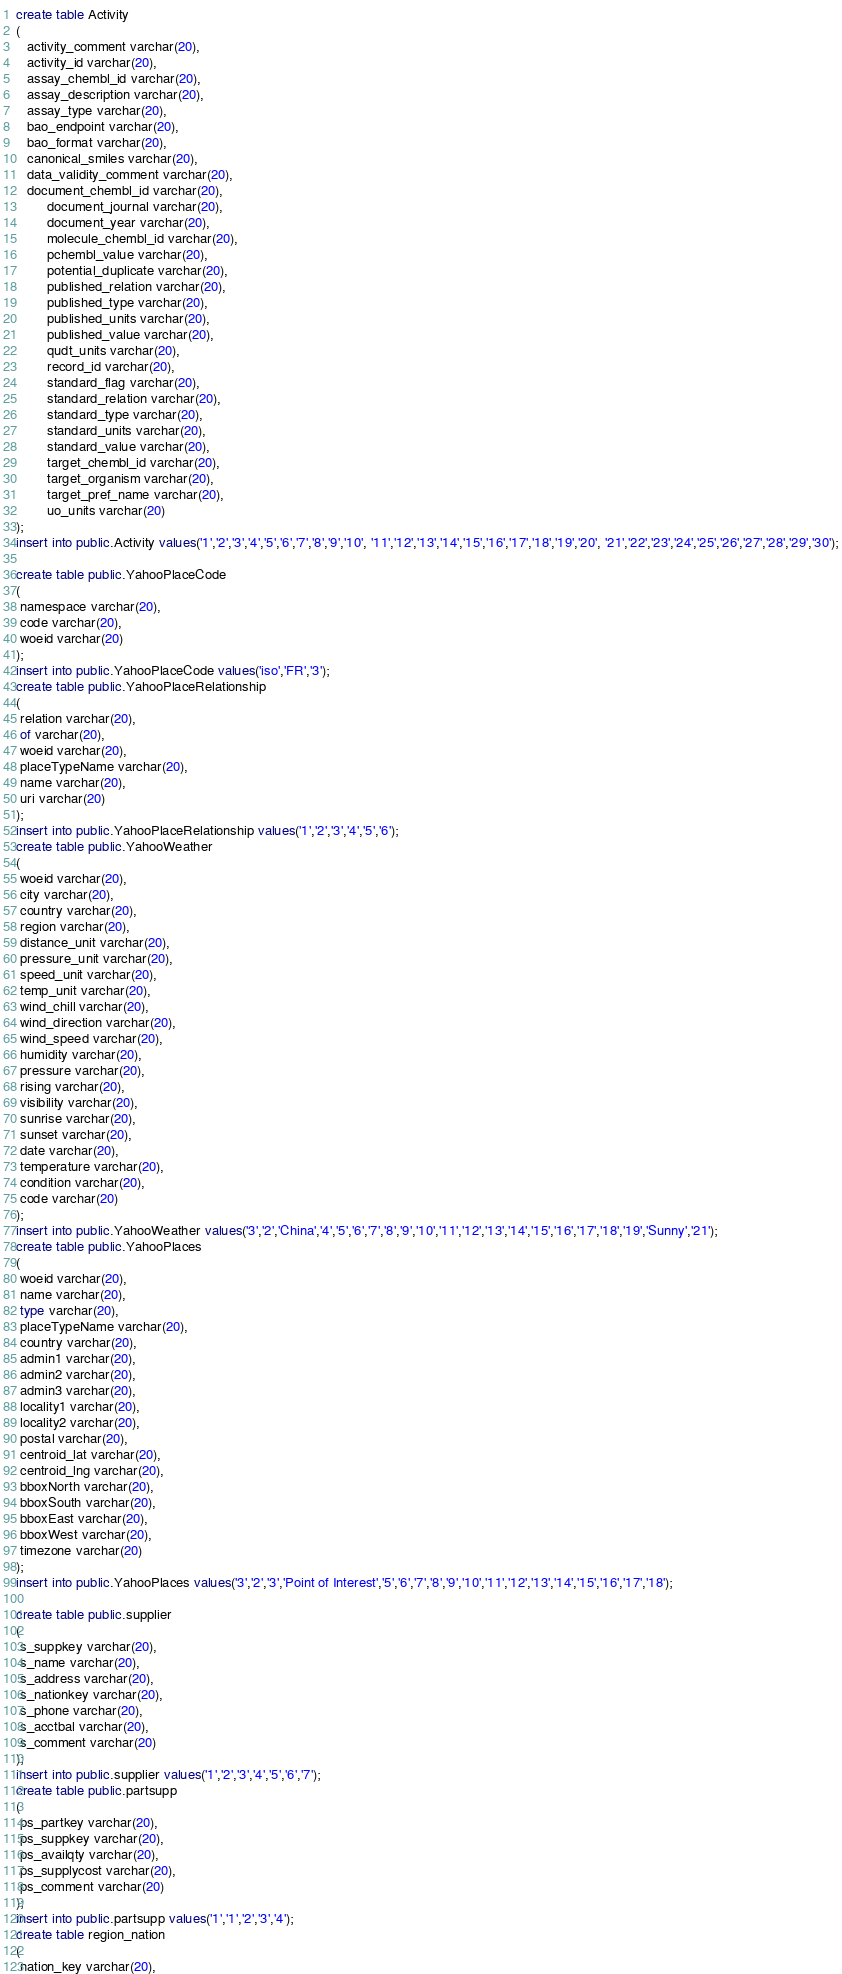<code> <loc_0><loc_0><loc_500><loc_500><_SQL_>create table Activity
(
   activity_comment varchar(20),
   activity_id varchar(20),
   assay_chembl_id varchar(20),
   assay_description varchar(20),
   assay_type varchar(20),
   bao_endpoint varchar(20),
   bao_format varchar(20),
   canonical_smiles varchar(20),
   data_validity_comment varchar(20),
   document_chembl_id varchar(20),
	    document_journal varchar(20),
		document_year varchar(20),
		molecule_chembl_id varchar(20),
		pchembl_value varchar(20),
		potential_duplicate varchar(20),
		published_relation varchar(20),
		published_type varchar(20),
		published_units varchar(20),
		published_value varchar(20),
		qudt_units varchar(20),
		record_id varchar(20),
		standard_flag varchar(20),
		standard_relation varchar(20),
		standard_type varchar(20),
		standard_units varchar(20),
		standard_value varchar(20),
		target_chembl_id varchar(20),
		target_organism varchar(20),
		target_pref_name varchar(20),
		uo_units varchar(20)
);
insert into public.Activity values('1','2','3','4','5','6','7','8','9','10', '11','12','13','14','15','16','17','18','19','20', '21','22','23','24','25','26','27','28','29','30');

create table public.YahooPlaceCode
(
 namespace varchar(20),
 code varchar(20),
 woeid varchar(20)
);
insert into public.YahooPlaceCode values('iso','FR','3');
create table public.YahooPlaceRelationship
(
 relation varchar(20),
 of varchar(20),
 woeid varchar(20),
 placeTypeName varchar(20),
 name varchar(20),
 uri varchar(20)
);
insert into public.YahooPlaceRelationship values('1','2','3','4','5','6');
create table public.YahooWeather
(
 woeid varchar(20),
 city varchar(20),
 country varchar(20),
 region varchar(20),
 distance_unit varchar(20),
 pressure_unit varchar(20),
 speed_unit varchar(20),
 temp_unit varchar(20),
 wind_chill varchar(20),
 wind_direction varchar(20),
 wind_speed varchar(20),
 humidity varchar(20),
 pressure varchar(20),
 rising varchar(20),
 visibility varchar(20),
 sunrise varchar(20),
 sunset varchar(20),
 date varchar(20),
 temperature varchar(20),
 condition varchar(20),
 code varchar(20)
);
insert into public.YahooWeather values('3','2','China','4','5','6','7','8','9','10','11','12','13','14','15','16','17','18','19','Sunny','21');
create table public.YahooPlaces
(
 woeid varchar(20),
 name varchar(20),
 type varchar(20),
 placeTypeName varchar(20),
 country varchar(20),
 admin1 varchar(20),
 admin2 varchar(20),
 admin3 varchar(20),
 locality1 varchar(20),
 locality2 varchar(20),
 postal varchar(20),
 centroid_lat varchar(20),
 centroid_lng varchar(20),
 bboxNorth varchar(20),
 bboxSouth varchar(20),
 bboxEast varchar(20),
 bboxWest varchar(20),
 timezone varchar(20)
);
insert into public.YahooPlaces values('3','2','3','Point of Interest','5','6','7','8','9','10','11','12','13','14','15','16','17','18');

create table public.supplier
(
 s_suppkey varchar(20),
 s_name varchar(20),
 s_address varchar(20),
 s_nationkey varchar(20),
 s_phone varchar(20),
 s_acctbal varchar(20),
 s_comment varchar(20)
);
insert into public.supplier values('1','2','3','4','5','6','7');
create table public.partsupp
(
 ps_partkey varchar(20),
 ps_suppkey varchar(20),
 ps_availqty varchar(20),
 ps_supplycost varchar(20),
 ps_comment varchar(20)
);
insert into public.partsupp values('1','1','2','3','4');
create table region_nation
(
 nation_key varchar(20),</code> 